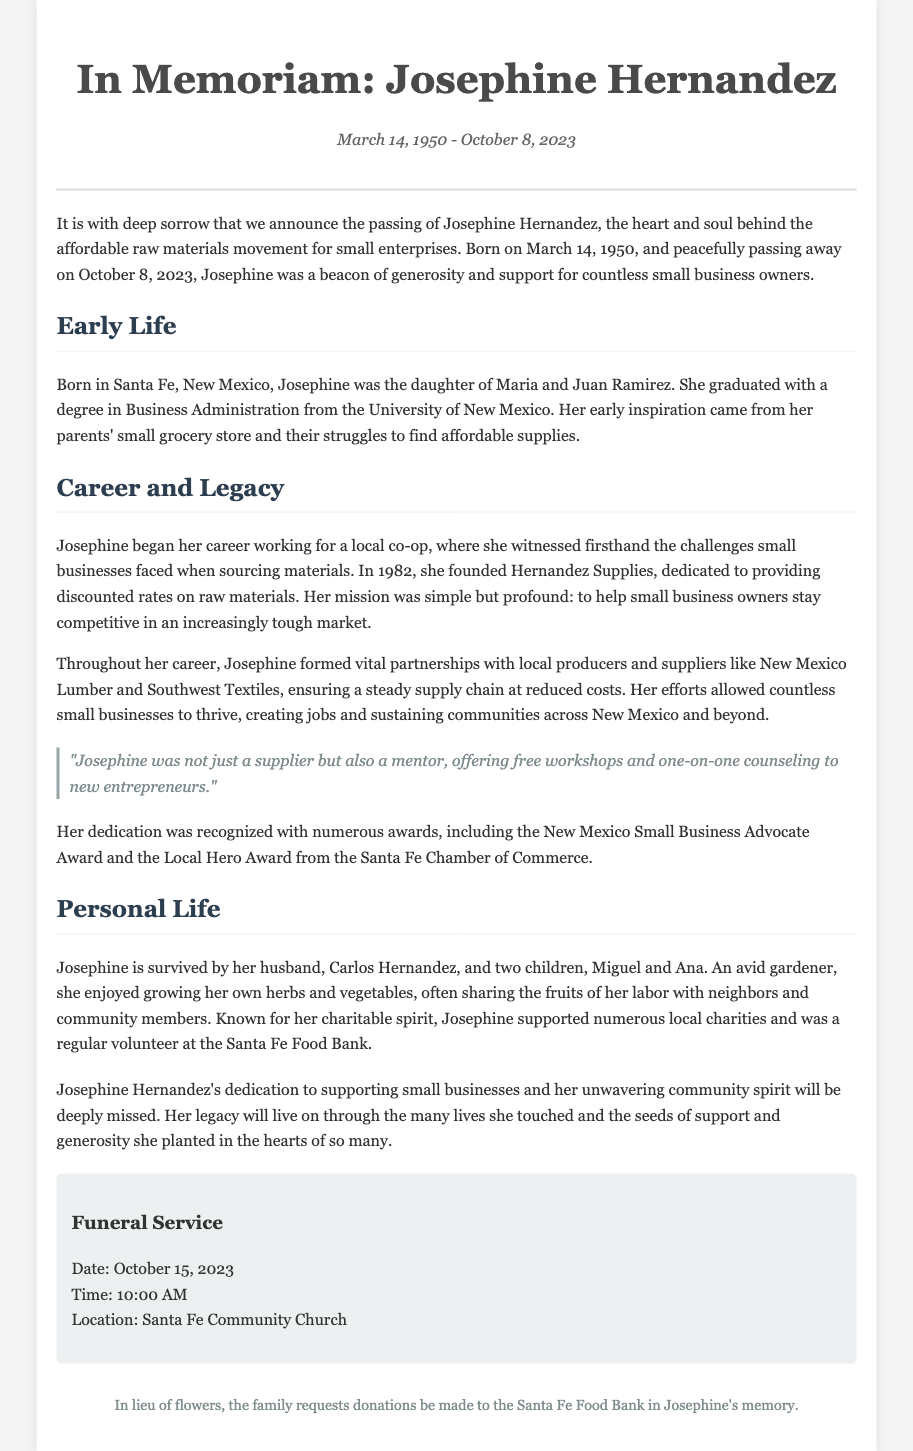What is Josephine Hernandez's birth date? The document states that Josephine was born on March 14, 1950.
Answer: March 14, 1950 When did Josephine pass away? The document mentions that Josephine passed away on October 8, 2023.
Answer: October 8, 2023 What was the name of Josephine's business? The obituary states that she founded Hernandez Supplies.
Answer: Hernandez Supplies What award did Josephine receive from the Santa Fe Chamber of Commerce? The document indicates she received the Local Hero Award.
Answer: Local Hero Award How many children did Josephine have? The obituary mentions she is survived by two children, Miguel and Ana.
Answer: Two What was Josephine's mission with her business? The document describes her mission as helping small business owners stay competitive.
Answer: Helping small business owners stay competitive What was the location of the funeral service? According to the document, the funeral service will be at Santa Fe Community Church.
Answer: Santa Fe Community Church What hobby did Josephine enjoy? The obituary mentions she was an avid gardener.
Answer: Gardener What was Josephine's support activity for new entrepreneurs? The document states that she offered free workshops and one-on-one counseling.
Answer: Free workshops and one-on-one counseling 